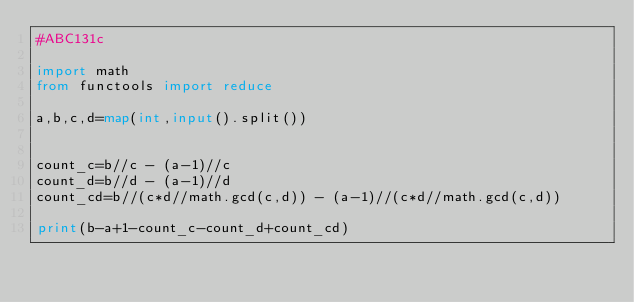<code> <loc_0><loc_0><loc_500><loc_500><_Python_>#ABC131c

import math
from functools import reduce

a,b,c,d=map(int,input().split())


count_c=b//c - (a-1)//c
count_d=b//d - (a-1)//d
count_cd=b//(c*d//math.gcd(c,d)) - (a-1)//(c*d//math.gcd(c,d))

print(b-a+1-count_c-count_d+count_cd)

</code> 